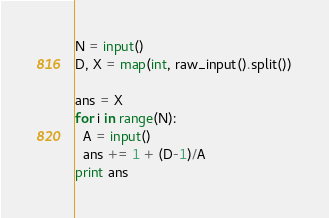<code> <loc_0><loc_0><loc_500><loc_500><_Python_>N = input()
D, X = map(int, raw_input().split())

ans = X
for i in range(N):
  A = input()
  ans += 1 + (D-1)/A
print ans
</code> 